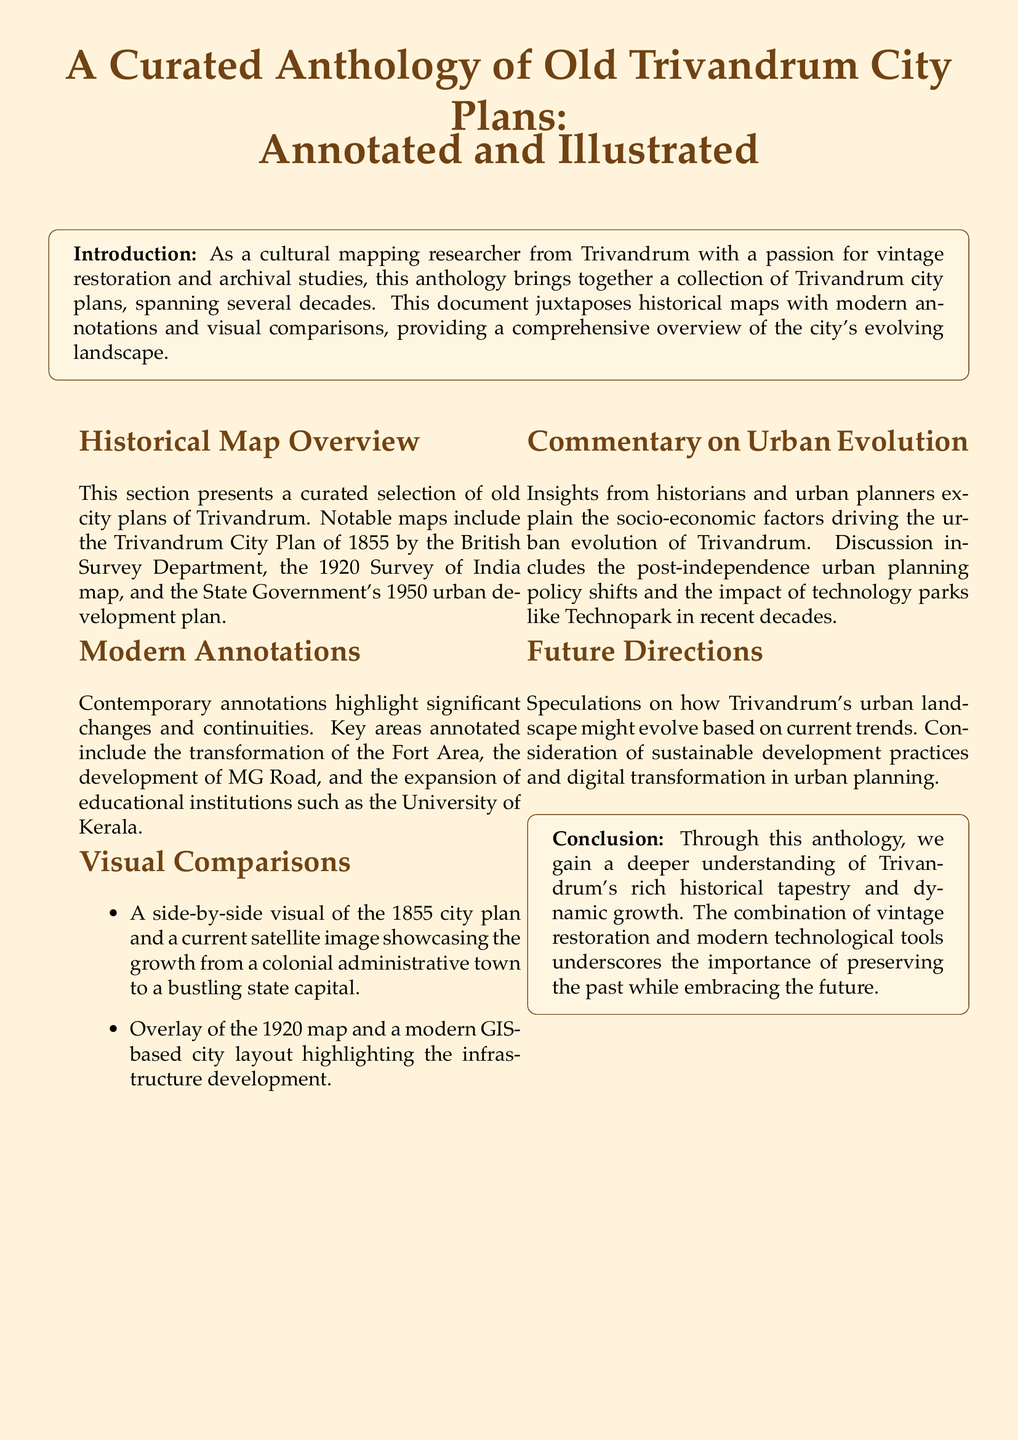What is the title of the document? The title is explicitly stated at the beginning of the document.
Answer: A Curated Anthology of Old Trivandrum City Plans: Annotated and Illustrated Which year is associated with the Trivandrum City Plan by the British Survey Department? The document specifies the year of this historical map in the overview section.
Answer: 1855 What type of changes are highlighted in the modern annotations? The document mentions specific categories of focus in the modern annotations section regarding city transformation.
Answer: Significant changes and continuities What is one of the key areas annotated in the document? The document lists specific areas that have been highlighted in the modern annotations section.
Answer: Fort Area Which map is overlaid with a modern GIS-based city layout? The document provides details about which historical map is compared to the current layout in the visual comparisons.
Answer: 1920 map Who provides insights on urban evolution in the commentary section? The document states who the commentators are within the commentary section.
Answer: Historians and urban planners What does the conclusion emphasize regarding the relationship between history and modern tools? The conclusion suggests a perspective on the importance of blending historical preservation with contemporary practices.
Answer: Importance of preserving the past while embracing the future What are two future considerations mentioned in the document? The document lists factors that may influence the future urban landscape of Trivandrum.
Answer: Sustainable development practices and digital transformation 